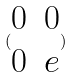Convert formula to latex. <formula><loc_0><loc_0><loc_500><loc_500>( \begin{matrix} 0 & 0 \\ 0 & e \end{matrix} )</formula> 